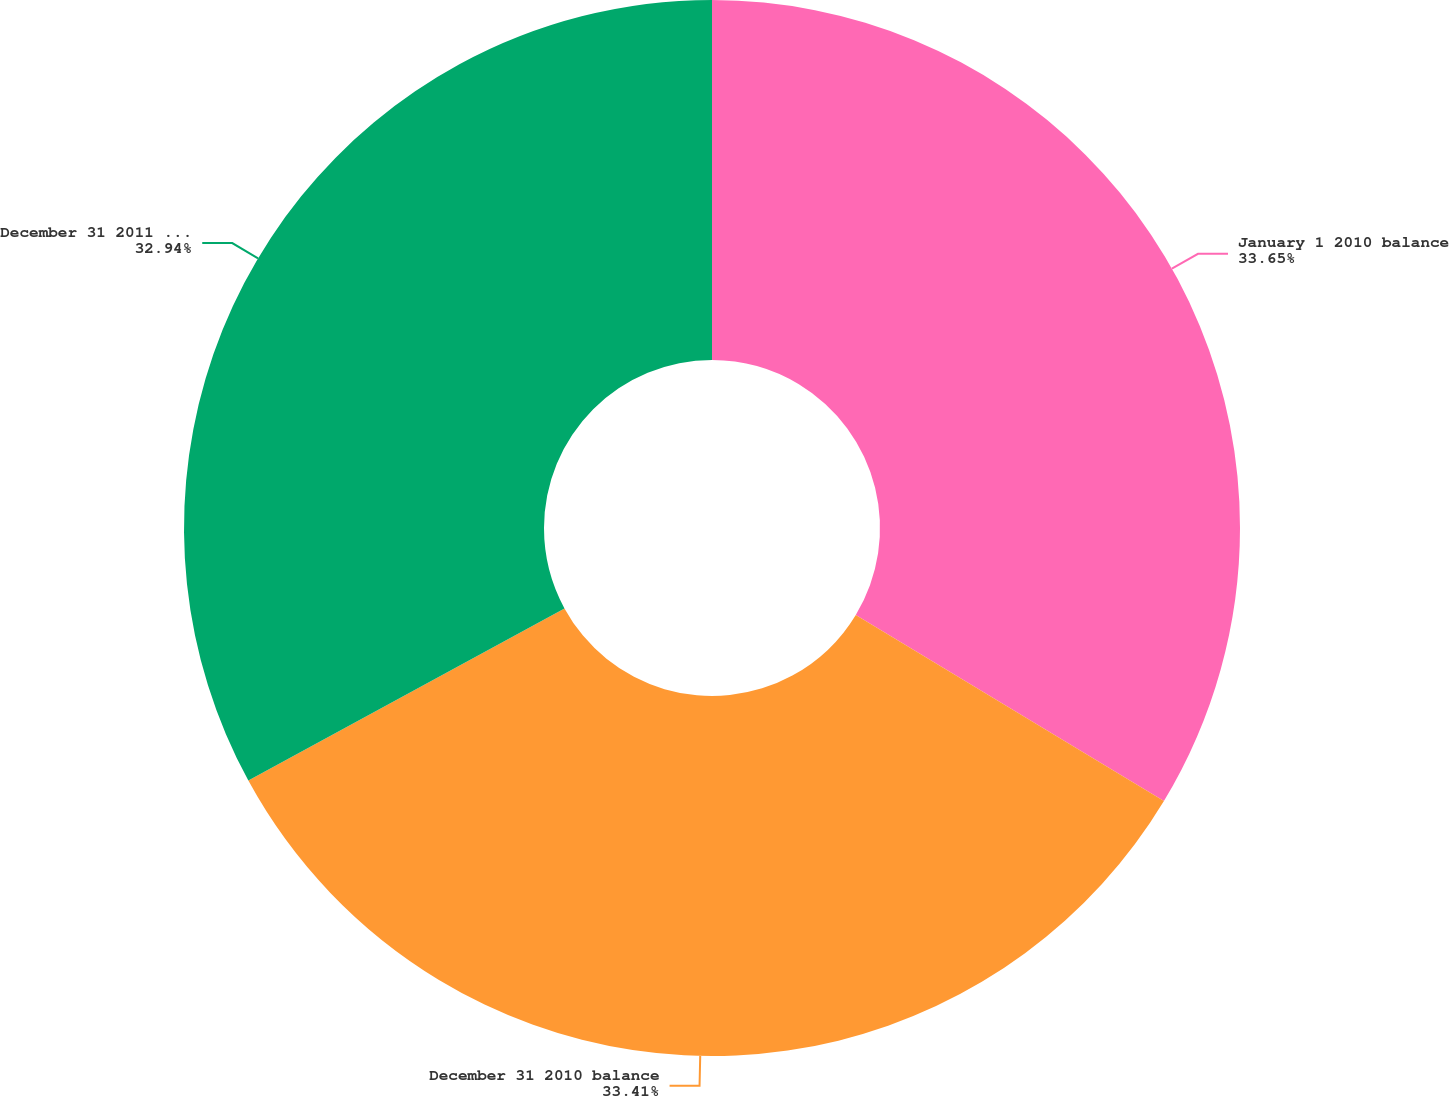Convert chart to OTSL. <chart><loc_0><loc_0><loc_500><loc_500><pie_chart><fcel>January 1 2010 balance<fcel>December 31 2010 balance<fcel>December 31 2011 balance<nl><fcel>33.65%<fcel>33.41%<fcel>32.94%<nl></chart> 